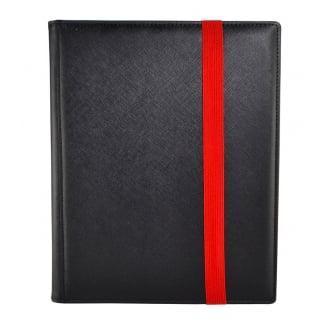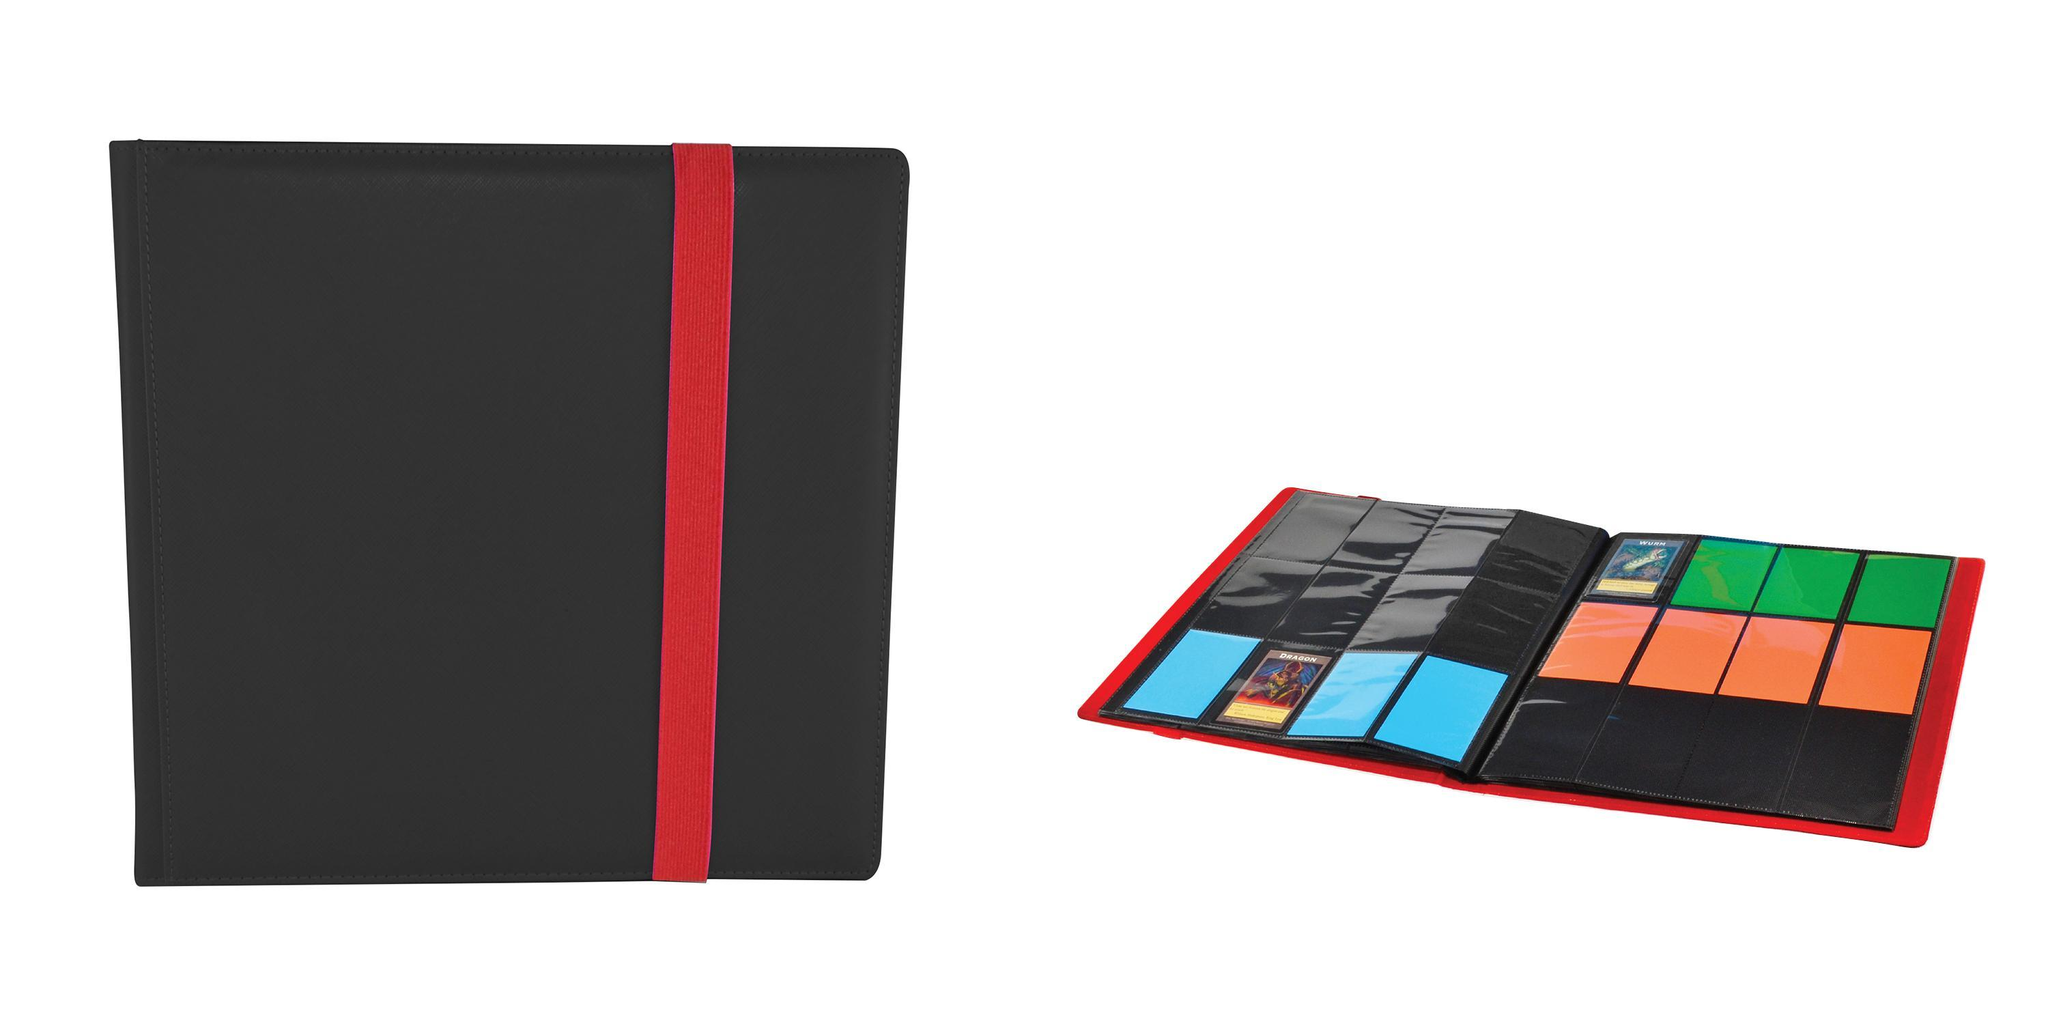The first image is the image on the left, the second image is the image on the right. For the images shown, is this caption "Only one folder is on the left image." true? Answer yes or no. Yes. 